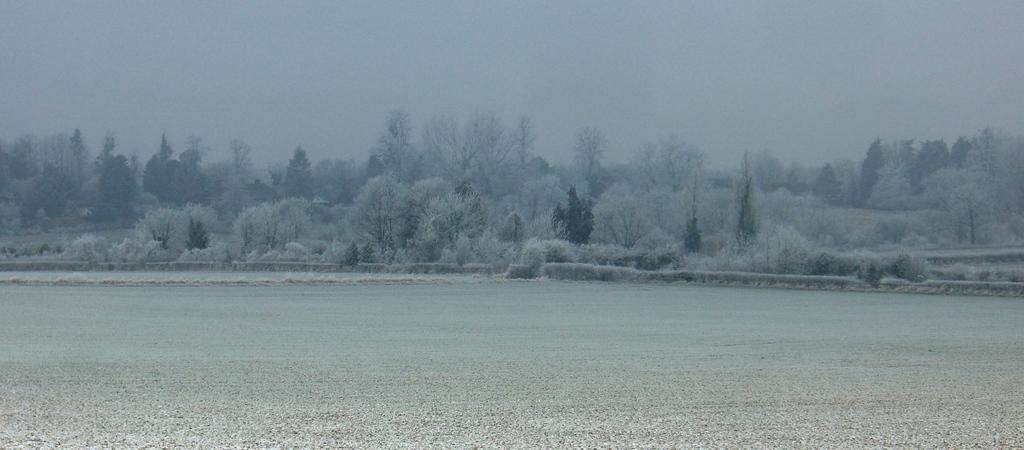What is the main feature of the image? There is a road in the image. What else can be seen in the image besides the road? Trees are present in the image. How are the trees in the image affected by the weather? The trees are covered with snow. What is visible in the background of the image? The sky is visible in the background of the image. Can you tell me which actor is holding the match in the image? There is no actor or match present in the image. What type of bread can be seen in the image? There is no bread present in the image. 